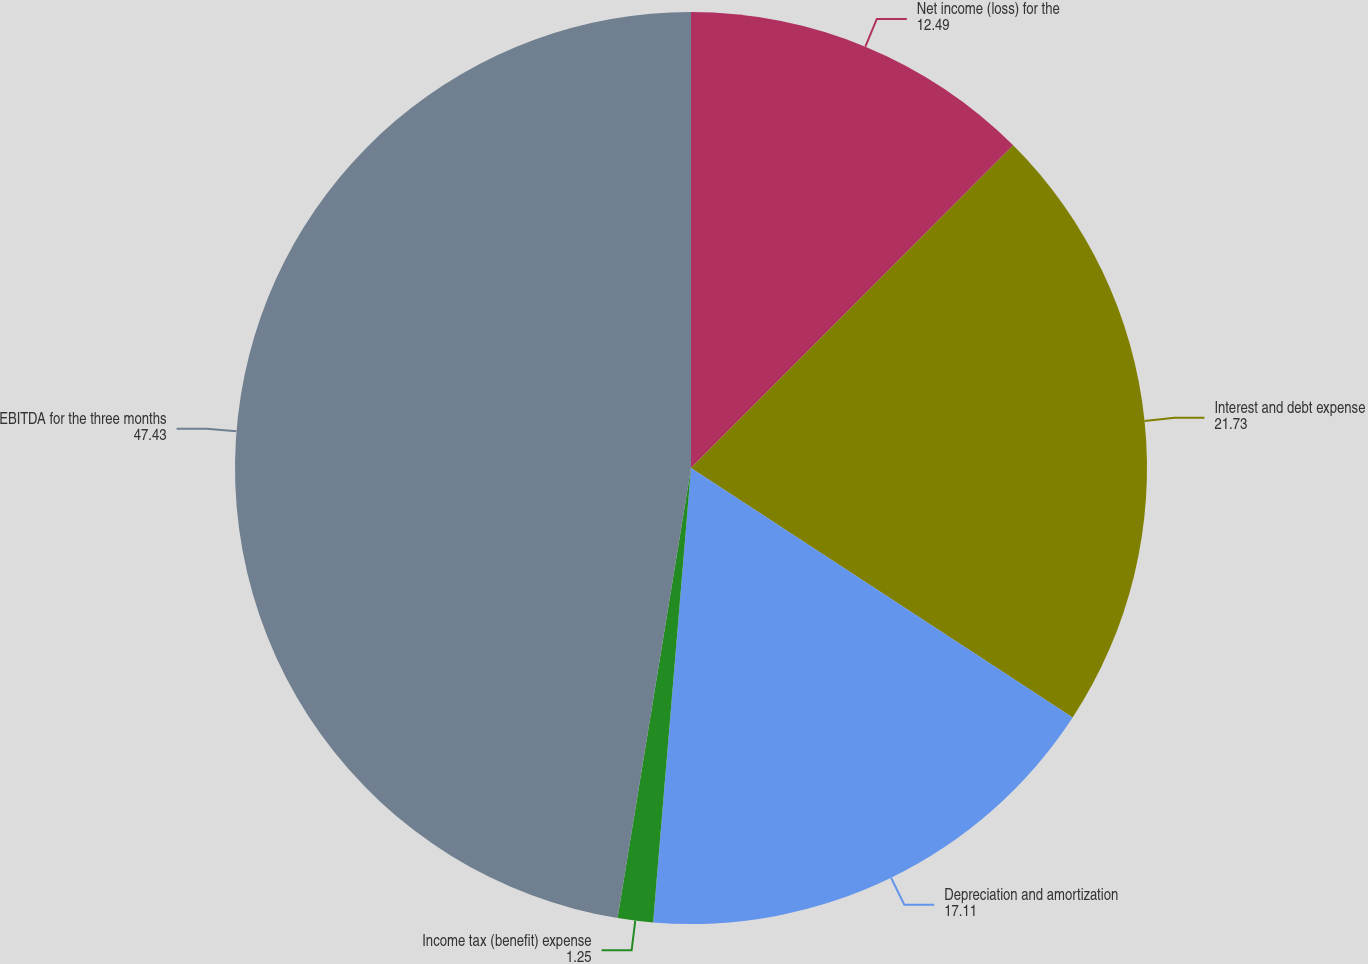Convert chart. <chart><loc_0><loc_0><loc_500><loc_500><pie_chart><fcel>Net income (loss) for the<fcel>Interest and debt expense<fcel>Depreciation and amortization<fcel>Income tax (benefit) expense<fcel>EBITDA for the three months<nl><fcel>12.49%<fcel>21.73%<fcel>17.11%<fcel>1.25%<fcel>47.43%<nl></chart> 